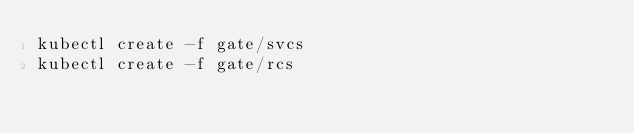Convert code to text. <code><loc_0><loc_0><loc_500><loc_500><_Bash_>kubectl create -f gate/svcs
kubectl create -f gate/rcs
</code> 